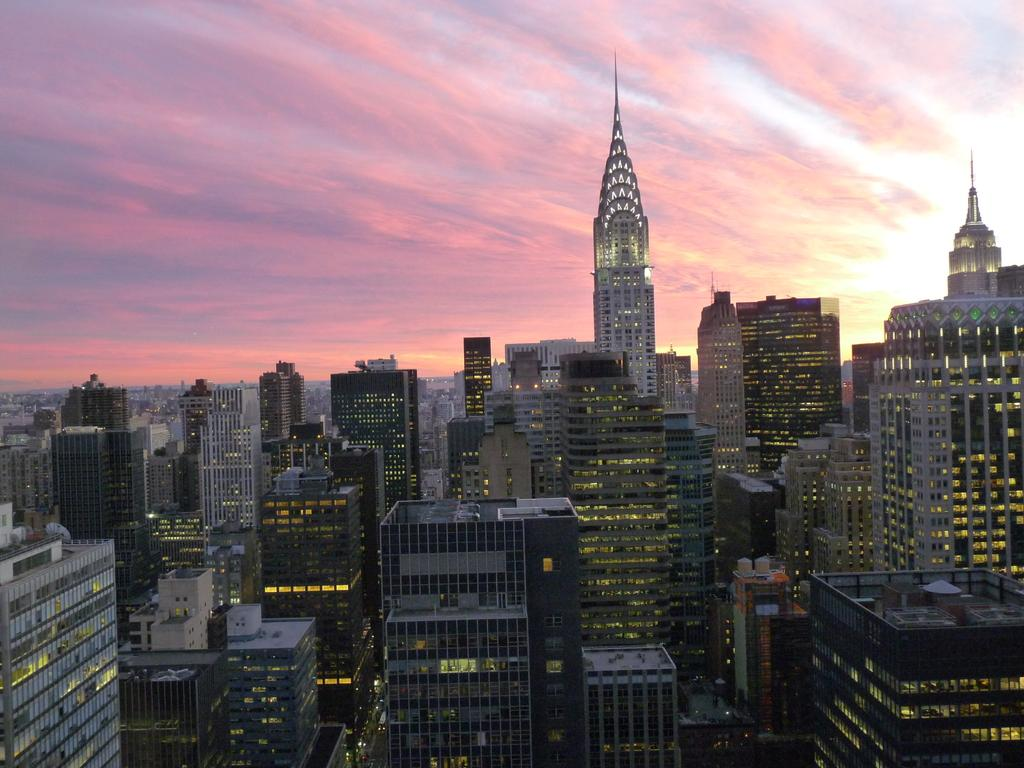What type of structures can be seen in the image? There are buildings in the image. What part of the natural environment is visible in the image? The sky is visible at the top of the image. What type of thrill can be experienced by the pencil in the image? There is no pencil present in the image, and therefore no such experience can be observed. 